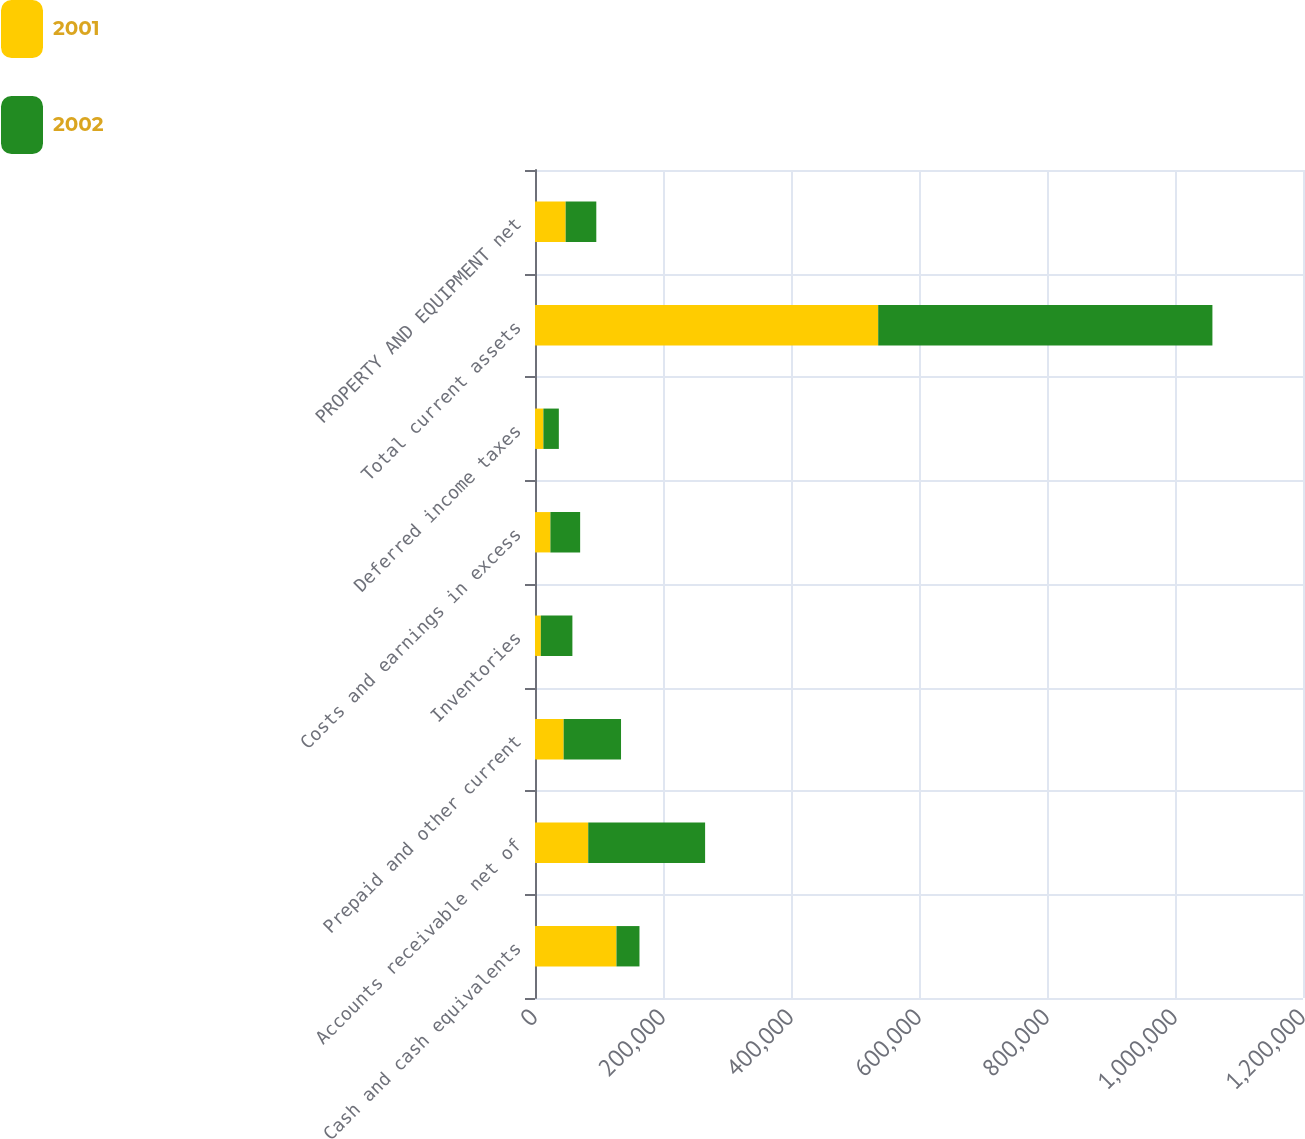Convert chart to OTSL. <chart><loc_0><loc_0><loc_500><loc_500><stacked_bar_chart><ecel><fcel>Cash and cash equivalents<fcel>Accounts receivable net of<fcel>Prepaid and other current<fcel>Inventories<fcel>Costs and earnings in excess<fcel>Deferred income taxes<fcel>Total current assets<fcel>PROPERTY AND EQUIPMENT net<nl><fcel>2001<fcel>127292<fcel>83177<fcel>44769<fcel>9092<fcel>24088<fcel>13111<fcel>536253<fcel>47892.5<nl><fcel>2002<fcel>35958<fcel>182612<fcel>89645<fcel>49332<fcel>46453<fcel>24136<fcel>522207<fcel>47892.5<nl></chart> 